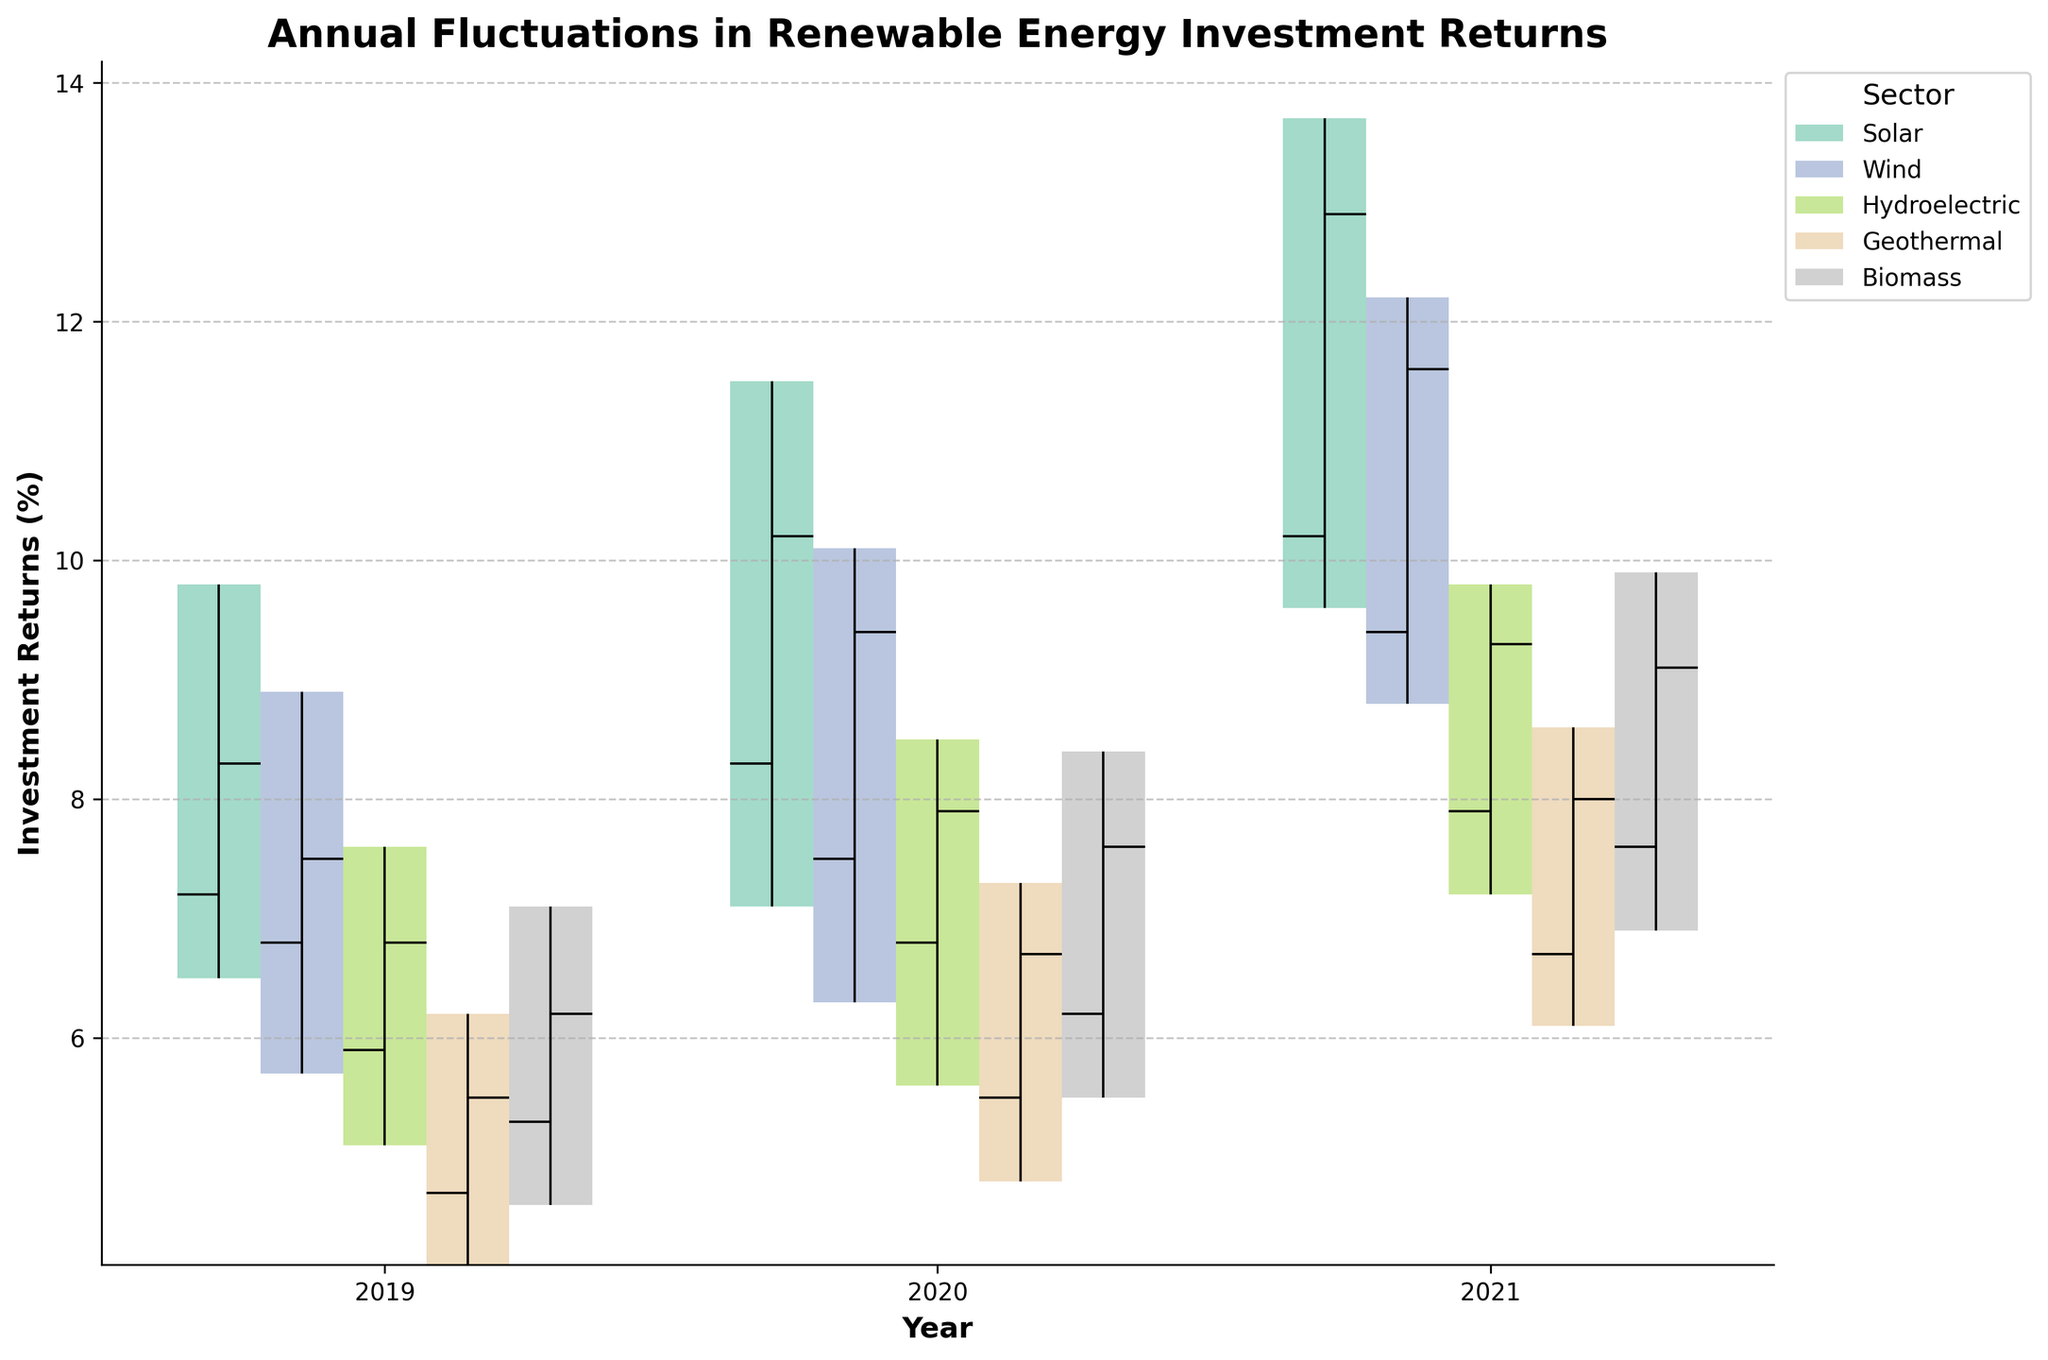What is the title of the chart? The title of the chart is displayed at the top center of the figure. It reads "Annual Fluctuations in Renewable Energy Investment Returns".
Answer: Annual Fluctuations in Renewable Energy Investment Returns Name the sectors included in the figure. The sectors are listed in the legend, which is located outside the top right corner of the chart. The sectors are Solar, Wind, Hydroelectric, Geothermal, and Biomass.
Answer: Solar, Wind, Hydroelectric, Geothermal, Biomass Which sector saw the highest investment return in any single year? To answer this, identify the highest peak (High value) for any sector across all years. The Solar sector in 2021 had the highest peak return at 13.7%.
Answer: Solar sector in 2021 Compare Solar and Wind sectors in 2020, which one had a higher closing return? Referring to the bars for Solar and Wind sectors in 2020, the Solar sector had a closing return of 10.2%, while the Wind sector had a closing return of 9.4%. Therefore, Solar had a higher closing return.
Answer: Solar Which year saw the highest opening investment return in Hydroelectric? Identify the opening returns of the Hydroelectric sector for each year and compare them. Hydroelectric had opening returns of 5.9%, 6.8%, and 7.9% for 2019, 2020, and 2021 respectively. The highest opening return was in 2021 with 7.9%.
Answer: 2021 What is the range of investment returns for Geothermal in 2021? The range is calculated by subtracting the Low value from the High value for Geothermal in 2021. The High is 8.6% and the Low is 6.1%, so the range is 8.6% - 6.1% = 2.5%.
Answer: 2.5% Did the Wind sector experience any years where the closing return was lower than the opening return? Compare the Open and Close values for the Wind sector for each year. In all years (2019, 2020, and 2021), the Close value is higher than the Open value (7.5 > 6.8, 9.4 > 7.5, 11.6 > 9.4), indicating no such year.
Answer: No How much did the investment return increase for the Biomass sector from 2019 to 2021? Calculate the difference between the closing returns in 2021 and 2019 for the Biomass sector: 9.1% (2021) - 6.2% (2019) = 2.9%.
Answer: 2.9% Which sector had the smallest fluctuation in returns across the years presented? Determine the fluctuation range (High - Low) for each sector across all years and find the smallest. Hydroelectric has the smallest fluctuations: max range for Hydroelectric is 2.5% (7.6-5.1 in 2019).
Answer: Hydroelectric On average, how did the closing returns for the Solar sector change from 2019 to 2021? Calculate the average change: the closing returns for Solar from 2019 to 2021 are 8.3%, 10.2%, and 12.9%. The average change is ((10.2-8.3) + (12.9-10.2)) / 2 = (1.9 + 2.7) / 2 = 2.3%.
Answer: 2.3% 